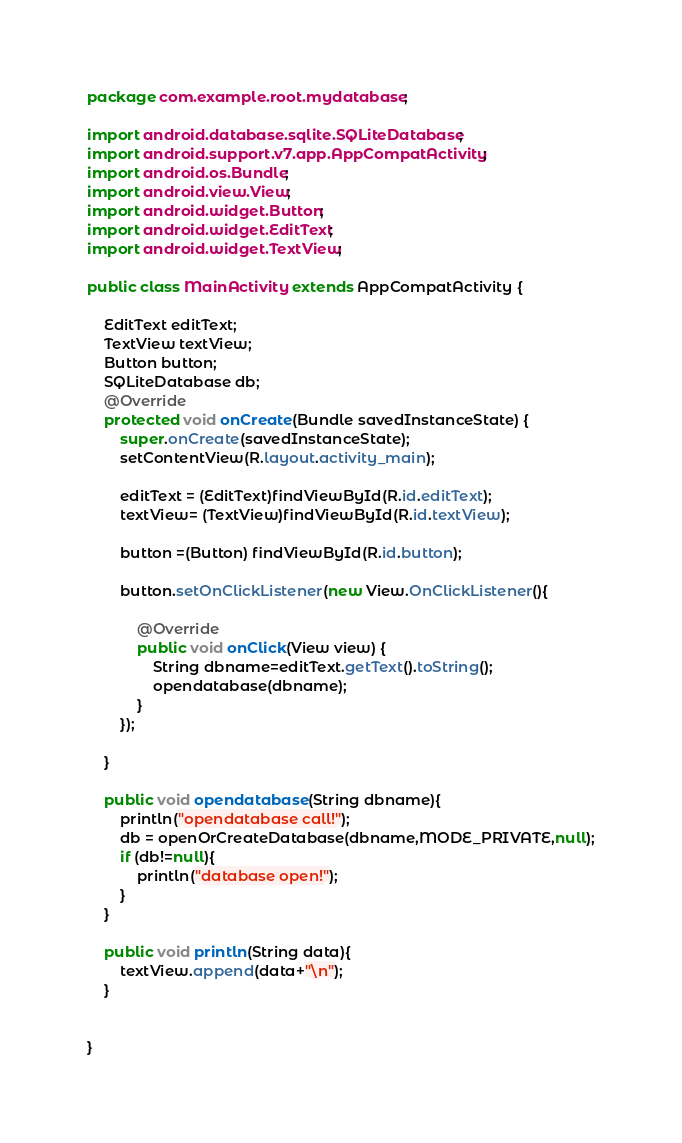Convert code to text. <code><loc_0><loc_0><loc_500><loc_500><_Java_>package com.example.root.mydatabase;

import android.database.sqlite.SQLiteDatabase;
import android.support.v7.app.AppCompatActivity;
import android.os.Bundle;
import android.view.View;
import android.widget.Button;
import android.widget.EditText;
import android.widget.TextView;

public class MainActivity extends AppCompatActivity {

    EditText editText;
    TextView textView;
    Button button;
    SQLiteDatabase db;
    @Override
    protected void onCreate(Bundle savedInstanceState) {
        super.onCreate(savedInstanceState);
        setContentView(R.layout.activity_main);

        editText = (EditText)findViewById(R.id.editText);
        textView= (TextView)findViewById(R.id.textView);

        button =(Button) findViewById(R.id.button);

        button.setOnClickListener(new View.OnClickListener(){

            @Override
            public void onClick(View view) {
                String dbname=editText.getText().toString();
                opendatabase(dbname);
            }
        });

    }

    public void opendatabase(String dbname){
        println("opendatabase call!");
        db = openOrCreateDatabase(dbname,MODE_PRIVATE,null);
        if (db!=null){
            println("database open!");
        }
    }

    public void println(String data){
        textView.append(data+"\n");
    }


}
</code> 